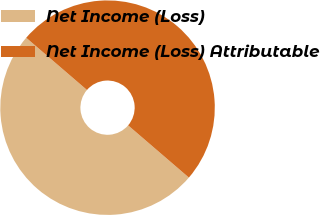Convert chart to OTSL. <chart><loc_0><loc_0><loc_500><loc_500><pie_chart><fcel>Net Income (Loss)<fcel>Net Income (Loss) Attributable<nl><fcel>50.0%<fcel>50.0%<nl></chart> 